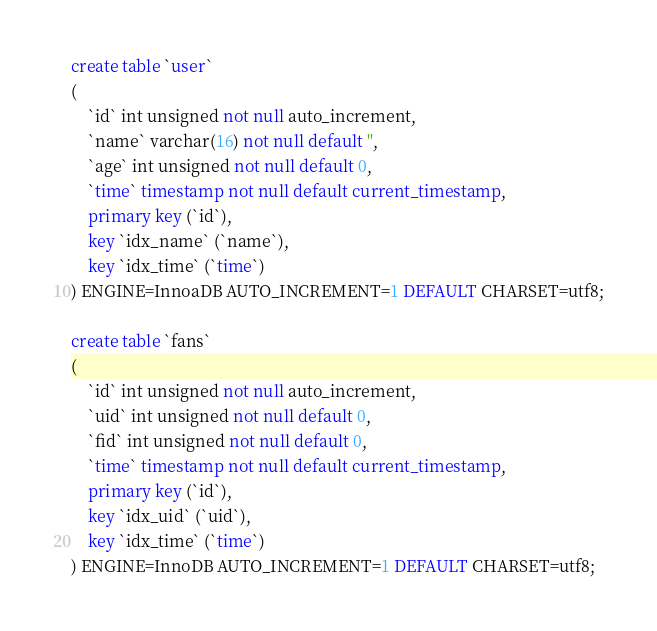Convert code to text. <code><loc_0><loc_0><loc_500><loc_500><_SQL_>create table `user`
(
    `id` int unsigned not null auto_increment,
    `name` varchar(16) not null default '',
    `age` int unsigned not null default 0,
    `time` timestamp not null default current_timestamp,
    primary key (`id`),
    key `idx_name` (`name`),
    key `idx_time` (`time`)
) ENGINE=InnoaDB AUTO_INCREMENT=1 DEFAULT CHARSET=utf8;

create table `fans`
(
    `id` int unsigned not null auto_increment,
    `uid` int unsigned not null default 0,
    `fid` int unsigned not null default 0,
    `time` timestamp not null default current_timestamp,
    primary key (`id`),
    key `idx_uid` (`uid`),
    key `idx_time` (`time`)
) ENGINE=InnoDB AUTO_INCREMENT=1 DEFAULT CHARSET=utf8;
</code> 